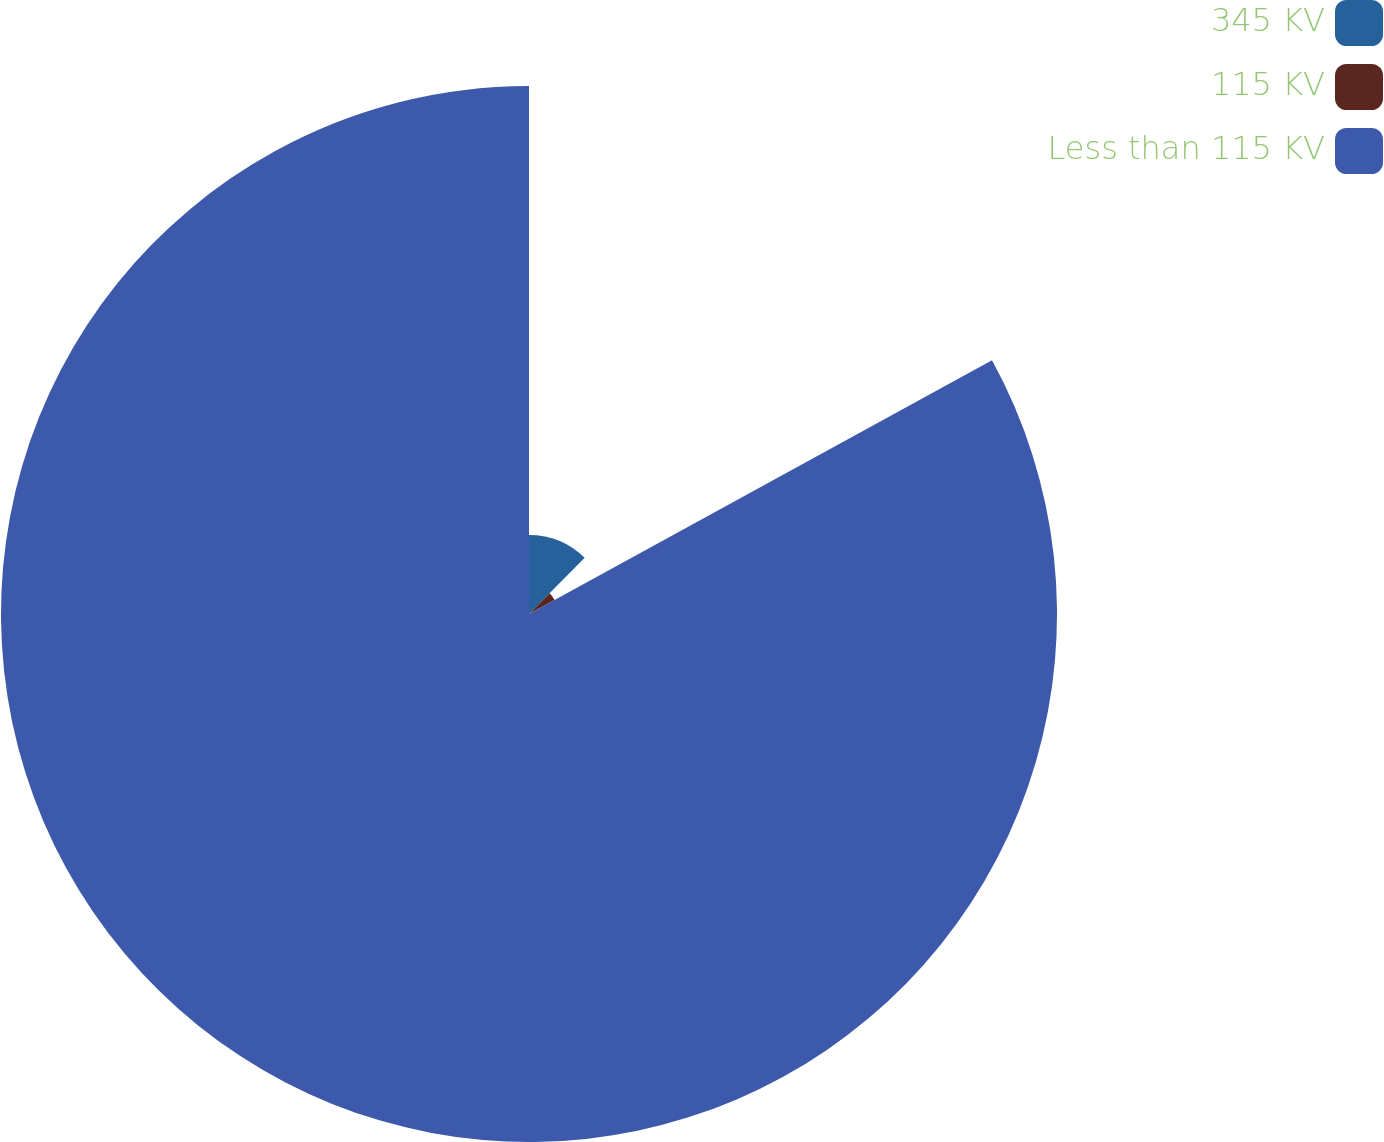Convert chart to OTSL. <chart><loc_0><loc_0><loc_500><loc_500><pie_chart><fcel>345 KV<fcel>115 KV<fcel>Less than 115 KV<nl><fcel>12.43%<fcel>4.59%<fcel>82.98%<nl></chart> 